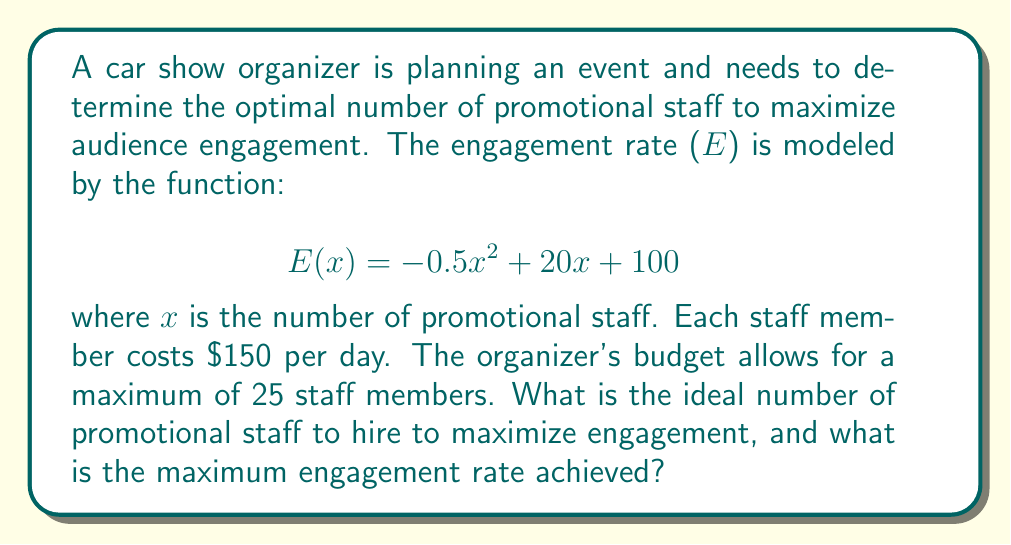Can you solve this math problem? To solve this optimization problem, we need to follow these steps:

1. Identify the constraints:
   The number of staff (x) must be non-negative and not exceed 25.
   $0 \leq x \leq 25$

2. Find the maximum of the quadratic function E(x):
   The function $E(x) = -0.5x^2 + 20x + 100$ is a quadratic function with a negative leading coefficient, so it has a maximum value.

3. Find the critical point by taking the derivative and setting it to zero:
   $$E'(x) = -x + 20$$
   $$-x + 20 = 0$$
   $$x = 20$$

4. Check if the critical point is within the constraints:
   The critical point x = 20 is within the range $0 \leq x \leq 25$, so it's a valid solution.

5. Calculate the maximum engagement rate:
   $$E(20) = -0.5(20)^2 + 20(20) + 100$$
   $$= -200 + 400 + 100$$
   $$= 300$$

Therefore, the ideal number of promotional staff is 20, and the maximum engagement rate achieved is 300.
Answer: The ideal number of promotional staff is 20, and the maximum engagement rate achieved is 300. 